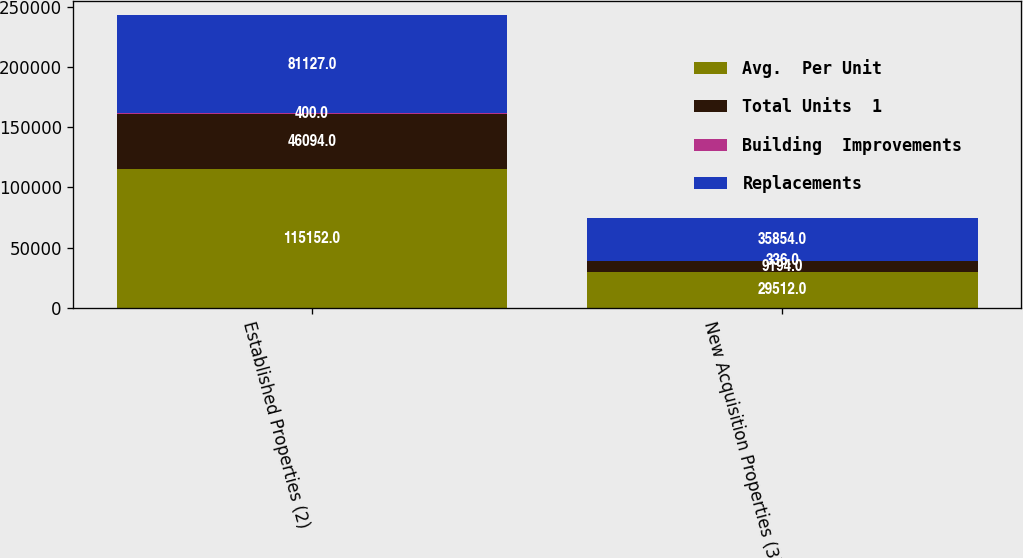<chart> <loc_0><loc_0><loc_500><loc_500><stacked_bar_chart><ecel><fcel>Established Properties (2)<fcel>New Acquisition Properties (3)<nl><fcel>Avg.  Per Unit<fcel>115152<fcel>29512<nl><fcel>Total Units  1<fcel>46094<fcel>9194<nl><fcel>Building  Improvements<fcel>400<fcel>336<nl><fcel>Replacements<fcel>81127<fcel>35854<nl></chart> 